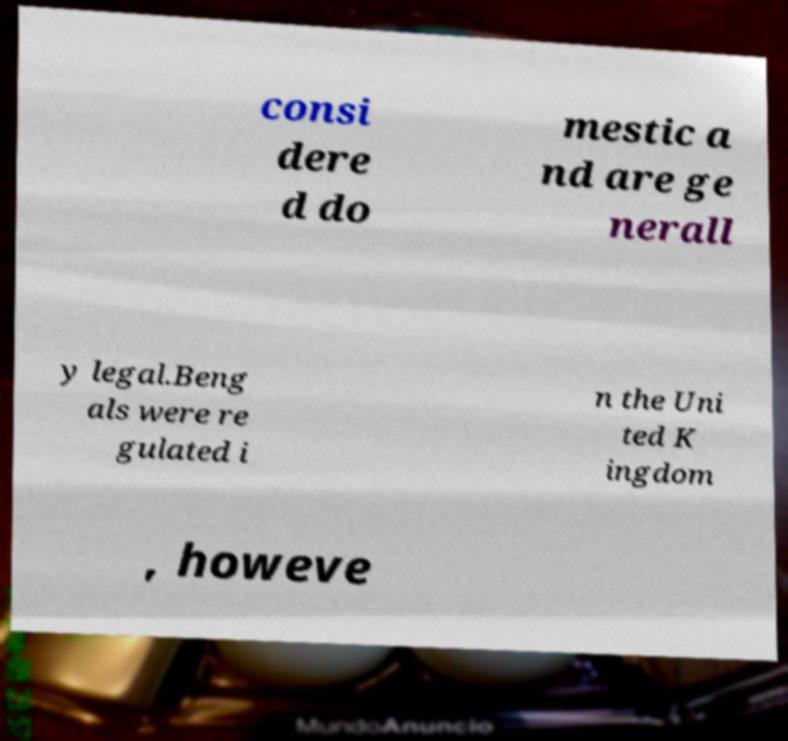Could you extract and type out the text from this image? consi dere d do mestic a nd are ge nerall y legal.Beng als were re gulated i n the Uni ted K ingdom , howeve 